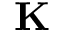<formula> <loc_0><loc_0><loc_500><loc_500>K</formula> 